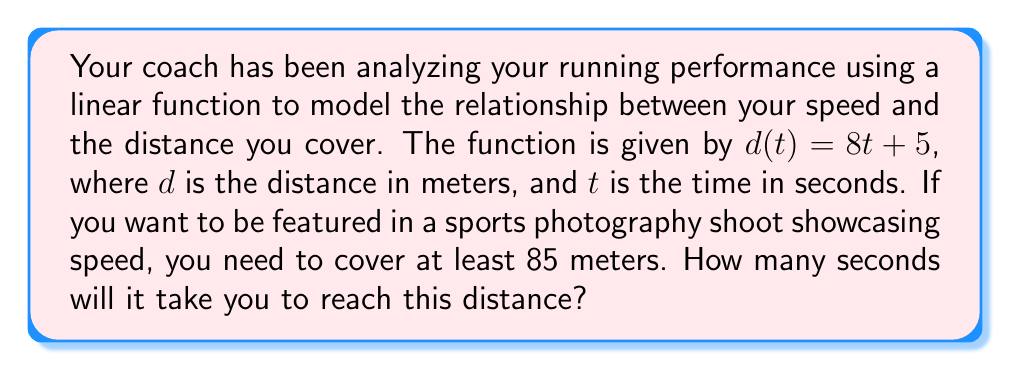Solve this math problem. Let's approach this step-by-step:

1) We are given a linear function $d(t) = 8t + 5$, where:
   - $d$ is the distance in meters
   - $t$ is the time in seconds
   - 8 is the slope (your speed in meters per second)
   - 5 is the y-intercept (initial distance)

2) We need to find $t$ when $d$ is at least 85 meters. So, we set up the equation:

   $$85 = 8t + 5$$

3) To solve for $t$, we first subtract 5 from both sides:

   $$80 = 8t$$

4) Now, we divide both sides by 8:

   $$\frac{80}{8} = t$$

5) Simplify:

   $$10 = t$$

Therefore, it will take you 10 seconds to reach 85 meters.

To verify, we can plug this back into the original function:

$$d(10) = 8(10) + 5 = 80 + 5 = 85$$

This confirms that at 10 seconds, you will have covered exactly 85 meters.
Answer: $t = 10$ seconds 